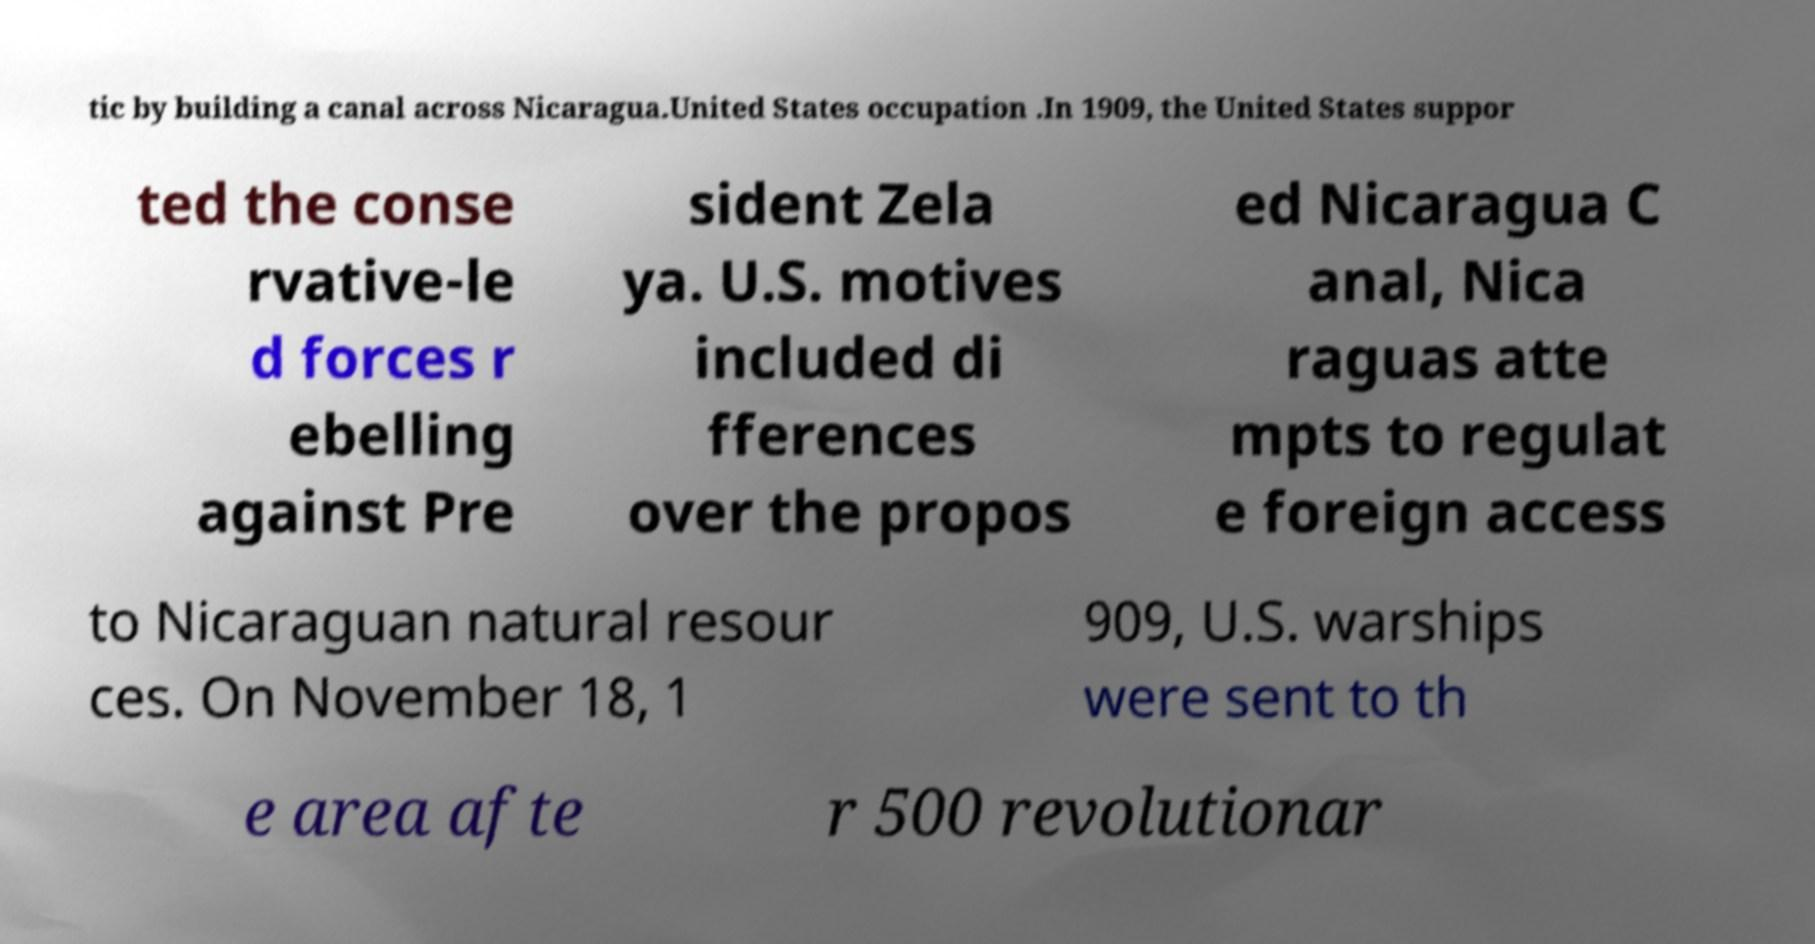Can you read and provide the text displayed in the image?This photo seems to have some interesting text. Can you extract and type it out for me? tic by building a canal across Nicaragua.United States occupation .In 1909, the United States suppor ted the conse rvative-le d forces r ebelling against Pre sident Zela ya. U.S. motives included di fferences over the propos ed Nicaragua C anal, Nica raguas atte mpts to regulat e foreign access to Nicaraguan natural resour ces. On November 18, 1 909, U.S. warships were sent to th e area afte r 500 revolutionar 